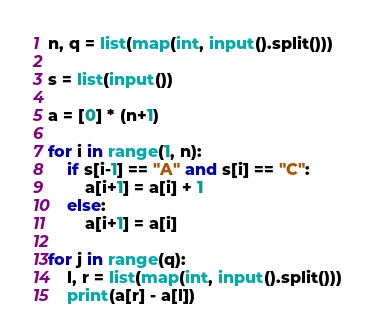<code> <loc_0><loc_0><loc_500><loc_500><_Python_>n, q = list(map(int, input().split()))

s = list(input())

a = [0] * (n+1)

for i in range(1, n):
    if s[i-1] == "A" and s[i] == "C":
        a[i+1] = a[i] + 1
    else:
        a[i+1] = a[i]

for j in range(q):
    l, r = list(map(int, input().split()))
    print(a[r] - a[l])

</code> 